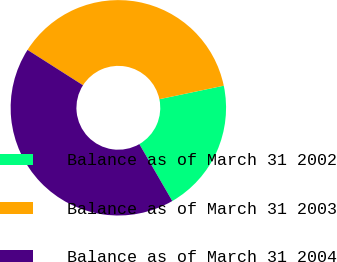<chart> <loc_0><loc_0><loc_500><loc_500><pie_chart><fcel>Balance as of March 31 2002<fcel>Balance as of March 31 2003<fcel>Balance as of March 31 2004<nl><fcel>19.94%<fcel>37.68%<fcel>42.38%<nl></chart> 